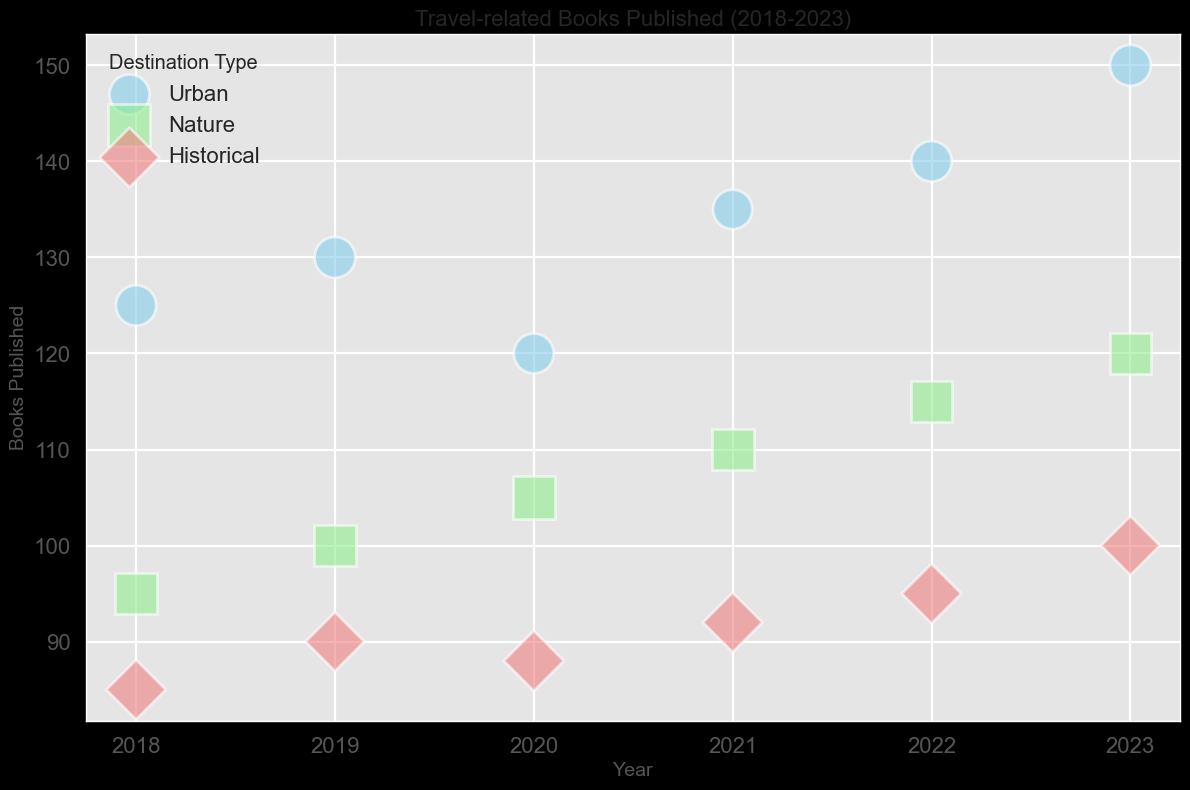what is the total number of books published about Nature destinations from 2018 to 2023? Check the 'Books Published' values for 'Nature' from 2018 to 2023 (95, 100, 105, 110, 115, 120) and sum them up: 95 + 100 + 105 + 110 + 115 + 120.
Answer: 645 Which year had the highest number of travel-related books published for Historical destinations? Compare the 'Books Published' values for 'Historical' across all years; 2018: 85, 2019: 90, 2020: 88, 2021: 92, 2022: 95, 2023: 100. The highest value is in 2023.
Answer: 2023 In which year did Urban destinations receive their lowest Average Reader Reviews? Look for the lowest 'Average Reader Reviews' for 'Urban' across all years; 2018: 4.2, 2019: 4.3, 2020: 4.1, 2021: 4.0, 2022: 4.2, 2023: 4.3. The lowest is in 2021.
Answer: 2021 How many more books were published about Urban destinations than Historical destinations in 2023? Subtract the 'Books Published' for 'Historical' from 'Urban' for the year 2023; 150 (Urban) - 100 (Historical).
Answer: 50 Which destination type had the highest average reader reviews in 2020? Compare 'Average Reader Reviews' for all destination types in 2020; Urban: 4.1, Nature: 4.6, Historical: 4.7. The highest is 'Historical'.
Answer: Historical What is the average number of books published annually for Urban destinations from 2018 to 2023? Sum 'Books Published' for 'Urban' from 2018 to 2023 (125, 130, 120, 135, 140, 150), then divide by the number of years (6): (125 + 130 + 120 + 135 + 140 + 150) / 6.
Answer: 133.33 What was the overall trend in 'Books Published' for Nature destinations from 2018 to 2023? Observe 'Books Published' for 'Nature' from 2018 to 2023; 95, 100, 105, 110, 115, 120. There is a consistent increase year by year.
Answer: Increasing In which year did Historical destinations see a decrease in the number of books published compared to the previous year, if any? Compare 'Books Published' for 'Historical' year over year to spot decreases; 2018 to 2019: 85 to 90 (increase), 2019 to 2020: 90 to 88 (decrease), 2020 to 2021: 88 to 92 (increase), 2021 to 2022: 92 to 95 (increase), 2022 to 2023: 95 to 100 (increase). The decrease happened from 2019 to 2020.
Answer: 2020 